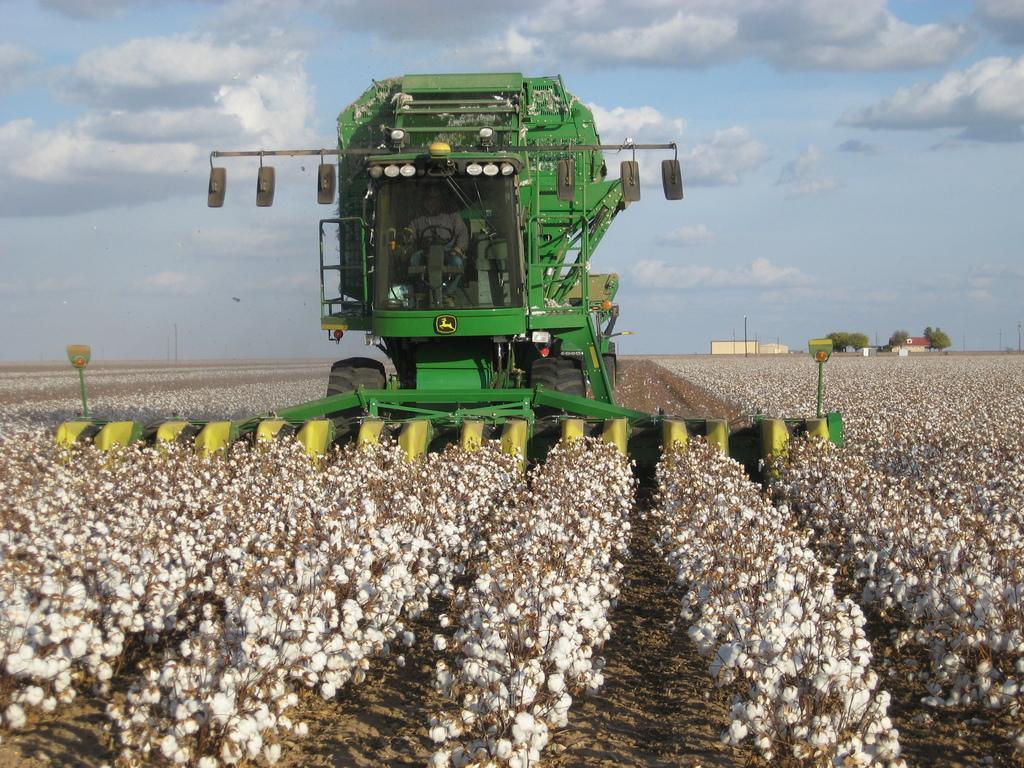Describe this image in one or two sentences. In this image I can see the ground, few plants which are brown and white in color, cotton to the plants and a huge machine which is green and yellow in color. I can see a person in the machine and in the background I can see few buildings, few trees, few poles and the sky. 